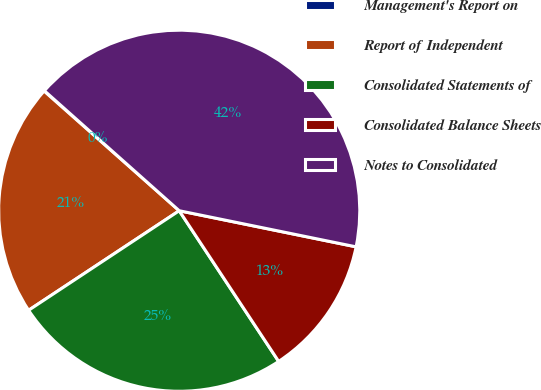Convert chart. <chart><loc_0><loc_0><loc_500><loc_500><pie_chart><fcel>Management's Report on<fcel>Report of Independent<fcel>Consolidated Statements of<fcel>Consolidated Balance Sheets<fcel>Notes to Consolidated<nl><fcel>0.04%<fcel>20.83%<fcel>24.99%<fcel>12.51%<fcel>41.63%<nl></chart> 